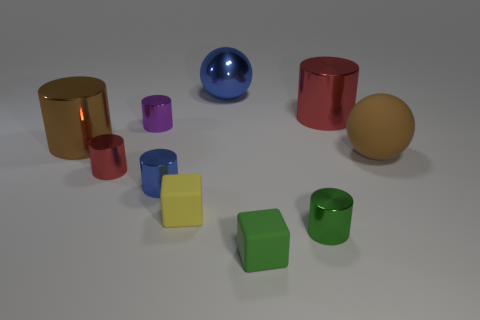How many blue metallic spheres have the same size as the brown metallic thing?
Make the answer very short. 1. What size is the shiny thing that is the same color as the big matte ball?
Give a very brief answer. Large. How big is the cylinder that is behind the large brown metallic cylinder and left of the small green matte block?
Give a very brief answer. Small. What number of large metallic objects are right of the blue shiny thing behind the red cylinder to the left of the yellow cube?
Provide a succinct answer. 1. Is there another sphere of the same color as the big matte ball?
Your answer should be very brief. No. What color is the other block that is the same size as the green cube?
Your answer should be very brief. Yellow. There is a big red object that is on the right side of the large metal thing that is behind the large metal cylinder behind the brown metallic cylinder; what shape is it?
Ensure brevity in your answer.  Cylinder. What number of metallic cylinders are to the right of the small rubber cube that is to the right of the big blue thing?
Ensure brevity in your answer.  2. There is a blue shiny thing behind the small blue thing; is it the same shape as the red object on the left side of the blue cylinder?
Make the answer very short. No. There is a big red metallic thing; what number of small blue things are behind it?
Provide a succinct answer. 0. 